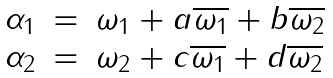Convert formula to latex. <formula><loc_0><loc_0><loc_500><loc_500>\begin{array} { l l l } \alpha _ { 1 } & = & \omega _ { 1 } + a \overline { \omega _ { 1 } } + b \overline { \omega _ { 2 } } \\ \alpha _ { 2 } & = & \omega _ { 2 } + c \overline { \omega _ { 1 } } + d \overline { \omega _ { 2 } } \end{array}</formula> 